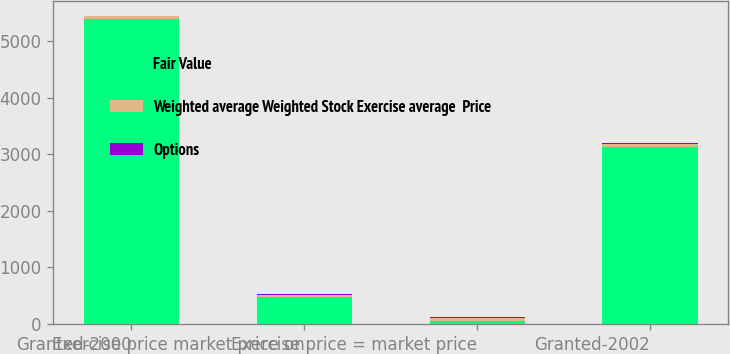Convert chart to OTSL. <chart><loc_0><loc_0><loc_500><loc_500><stacked_bar_chart><ecel><fcel>Granted-2000<fcel>Exercise price market price on<fcel>Exercise price = market price<fcel>Granted-2002<nl><fcel>Fair Value<fcel>5389<fcel>480<fcel>43.87<fcel>3122<nl><fcel>Weighted average Weighted Stock Exercise average  Price<fcel>43.87<fcel>33.21<fcel>61.2<fcel>62.28<nl><fcel>Options<fcel>6.86<fcel>23.69<fcel>11.24<fcel>10.91<nl></chart> 